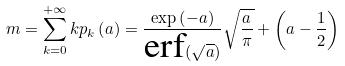<formula> <loc_0><loc_0><loc_500><loc_500>m = \sum _ { k = 0 } ^ { + \infty } k p _ { k } \left ( a \right ) = \frac { \exp \left ( - a \right ) } { \text {erf} ( \sqrt { a } ) } \sqrt { \frac { a } { \pi } } + \left ( a - \frac { 1 } { 2 } \right )</formula> 